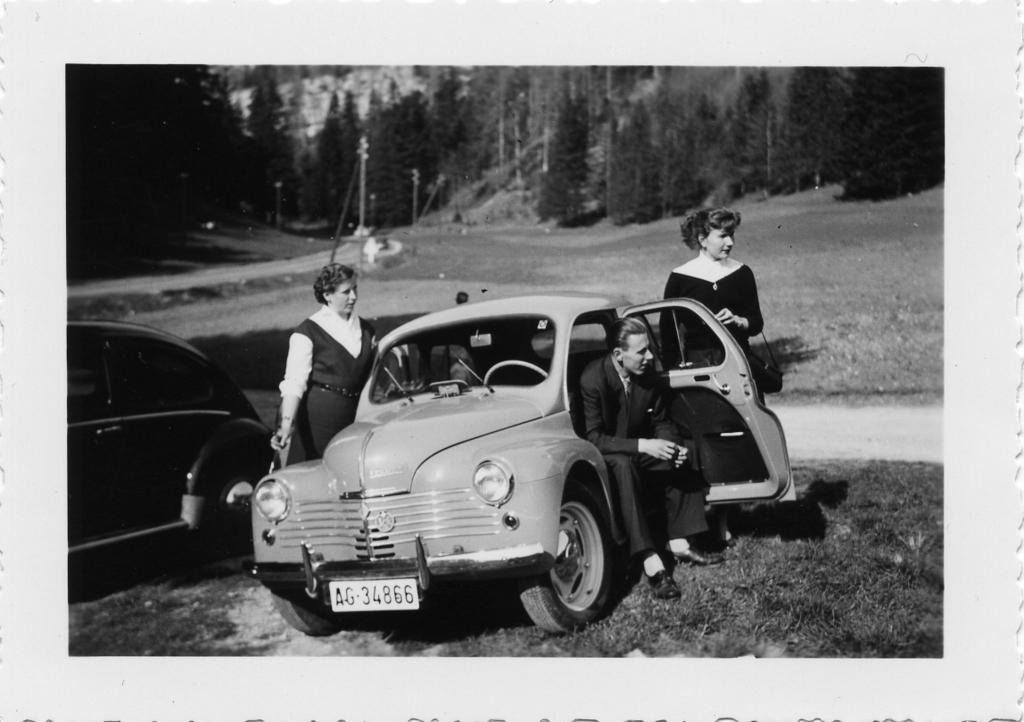What is the guy in the image doing? The guy is sitting inside a car in the image. Who else is present in the image besides the guy in the car? There are two people standing outside the car in the image. What can be seen to the left of the car in the image? There is another car to the left of the image. What is visible in the background of the image? There are many trees in the background of the image. What type of yam is being cooked in the image? There is no yam or cooking activity present in the image. What type of camera is being used to take the picture? The image does not show any camera being used to take the picture. 